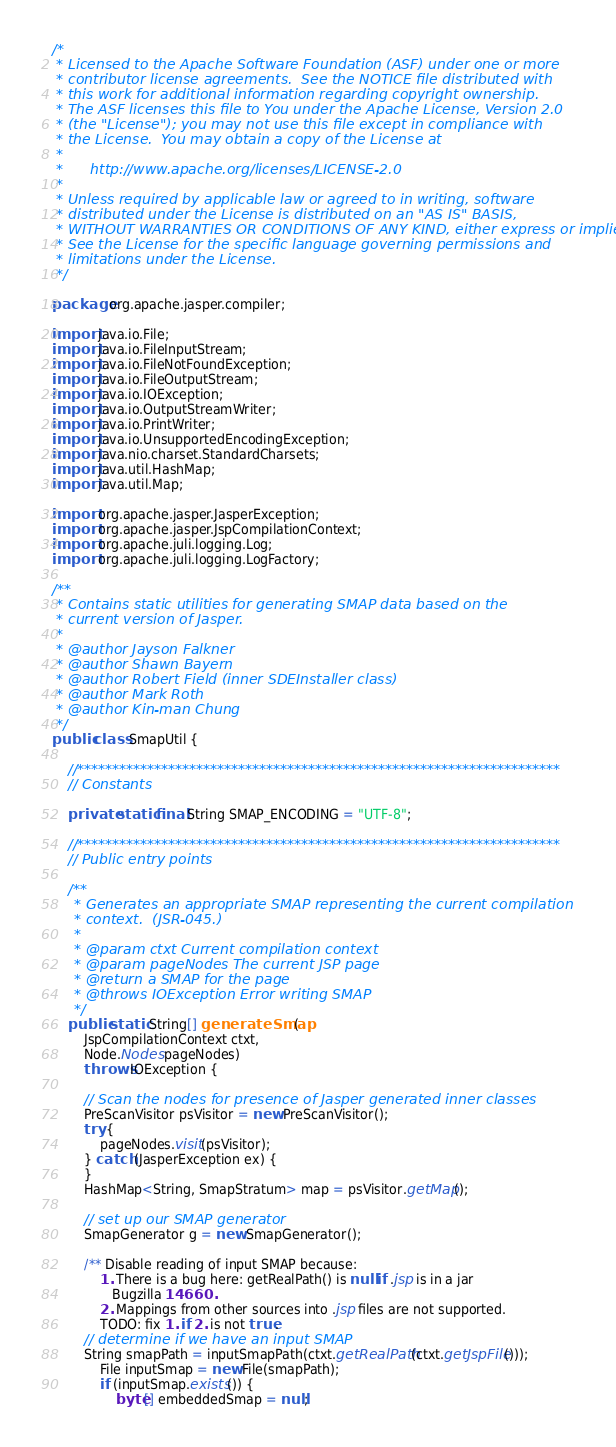<code> <loc_0><loc_0><loc_500><loc_500><_Java_>/*
 * Licensed to the Apache Software Foundation (ASF) under one or more
 * contributor license agreements.  See the NOTICE file distributed with
 * this work for additional information regarding copyright ownership.
 * The ASF licenses this file to You under the Apache License, Version 2.0
 * (the "License"); you may not use this file except in compliance with
 * the License.  You may obtain a copy of the License at
 *
 *      http://www.apache.org/licenses/LICENSE-2.0
 *
 * Unless required by applicable law or agreed to in writing, software
 * distributed under the License is distributed on an "AS IS" BASIS,
 * WITHOUT WARRANTIES OR CONDITIONS OF ANY KIND, either express or implied.
 * See the License for the specific language governing permissions and
 * limitations under the License.
 */

package org.apache.jasper.compiler;

import java.io.File;
import java.io.FileInputStream;
import java.io.FileNotFoundException;
import java.io.FileOutputStream;
import java.io.IOException;
import java.io.OutputStreamWriter;
import java.io.PrintWriter;
import java.io.UnsupportedEncodingException;
import java.nio.charset.StandardCharsets;
import java.util.HashMap;
import java.util.Map;

import org.apache.jasper.JasperException;
import org.apache.jasper.JspCompilationContext;
import org.apache.juli.logging.Log;
import org.apache.juli.logging.LogFactory;

/**
 * Contains static utilities for generating SMAP data based on the
 * current version of Jasper.
 *
 * @author Jayson Falkner
 * @author Shawn Bayern
 * @author Robert Field (inner SDEInstaller class)
 * @author Mark Roth
 * @author Kin-man Chung
 */
public class SmapUtil {

    //*********************************************************************
    // Constants

    private static final String SMAP_ENCODING = "UTF-8";

    //*********************************************************************
    // Public entry points

    /**
     * Generates an appropriate SMAP representing the current compilation
     * context.  (JSR-045.)
     *
     * @param ctxt Current compilation context
     * @param pageNodes The current JSP page
     * @return a SMAP for the page
     * @throws IOException Error writing SMAP
     */
    public static String[] generateSmap(
        JspCompilationContext ctxt,
        Node.Nodes pageNodes)
        throws IOException {

        // Scan the nodes for presence of Jasper generated inner classes
        PreScanVisitor psVisitor = new PreScanVisitor();
        try {
            pageNodes.visit(psVisitor);
        } catch (JasperException ex) {
        }
        HashMap<String, SmapStratum> map = psVisitor.getMap();

        // set up our SMAP generator
        SmapGenerator g = new SmapGenerator();

        /** Disable reading of input SMAP because:
            1. There is a bug here: getRealPath() is null if .jsp is in a jar
               Bugzilla 14660.
            2. Mappings from other sources into .jsp files are not supported.
            TODO: fix 1. if 2. is not true.
        // determine if we have an input SMAP
        String smapPath = inputSmapPath(ctxt.getRealPath(ctxt.getJspFile()));
            File inputSmap = new File(smapPath);
            if (inputSmap.exists()) {
                byte[] embeddedSmap = null;</code> 